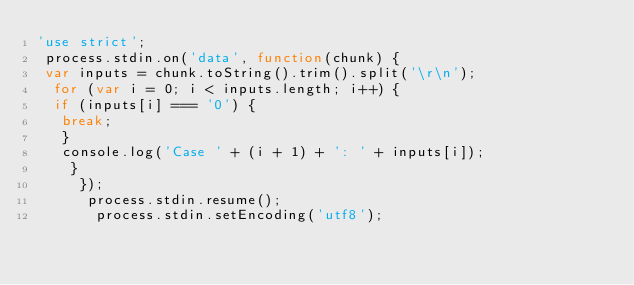<code> <loc_0><loc_0><loc_500><loc_500><_JavaScript_>'use strict';
 process.stdin.on('data', function(chunk) { 
 var inputs = chunk.toString().trim().split('\r\n');
  for (var i = 0; i < inputs.length; i++) { 
  if (inputs[i] === '0') {
   break; 
   } 
   console.log('Case ' + (i + 1) + ': ' + inputs[i]);
    }
     });
      process.stdin.resume();
       process.stdin.setEncoding('utf8');</code> 